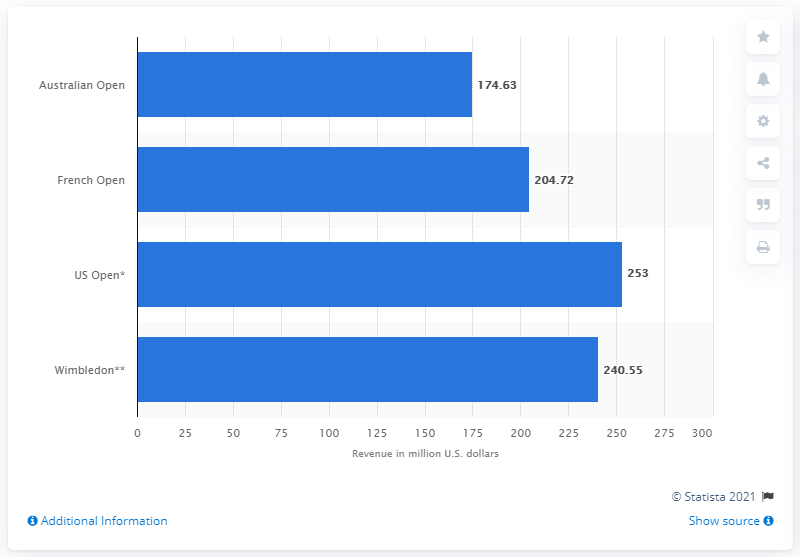Identify some key points in this picture. In 2015, the revenue generated from the Australian Open was 174.63 million dollars. 